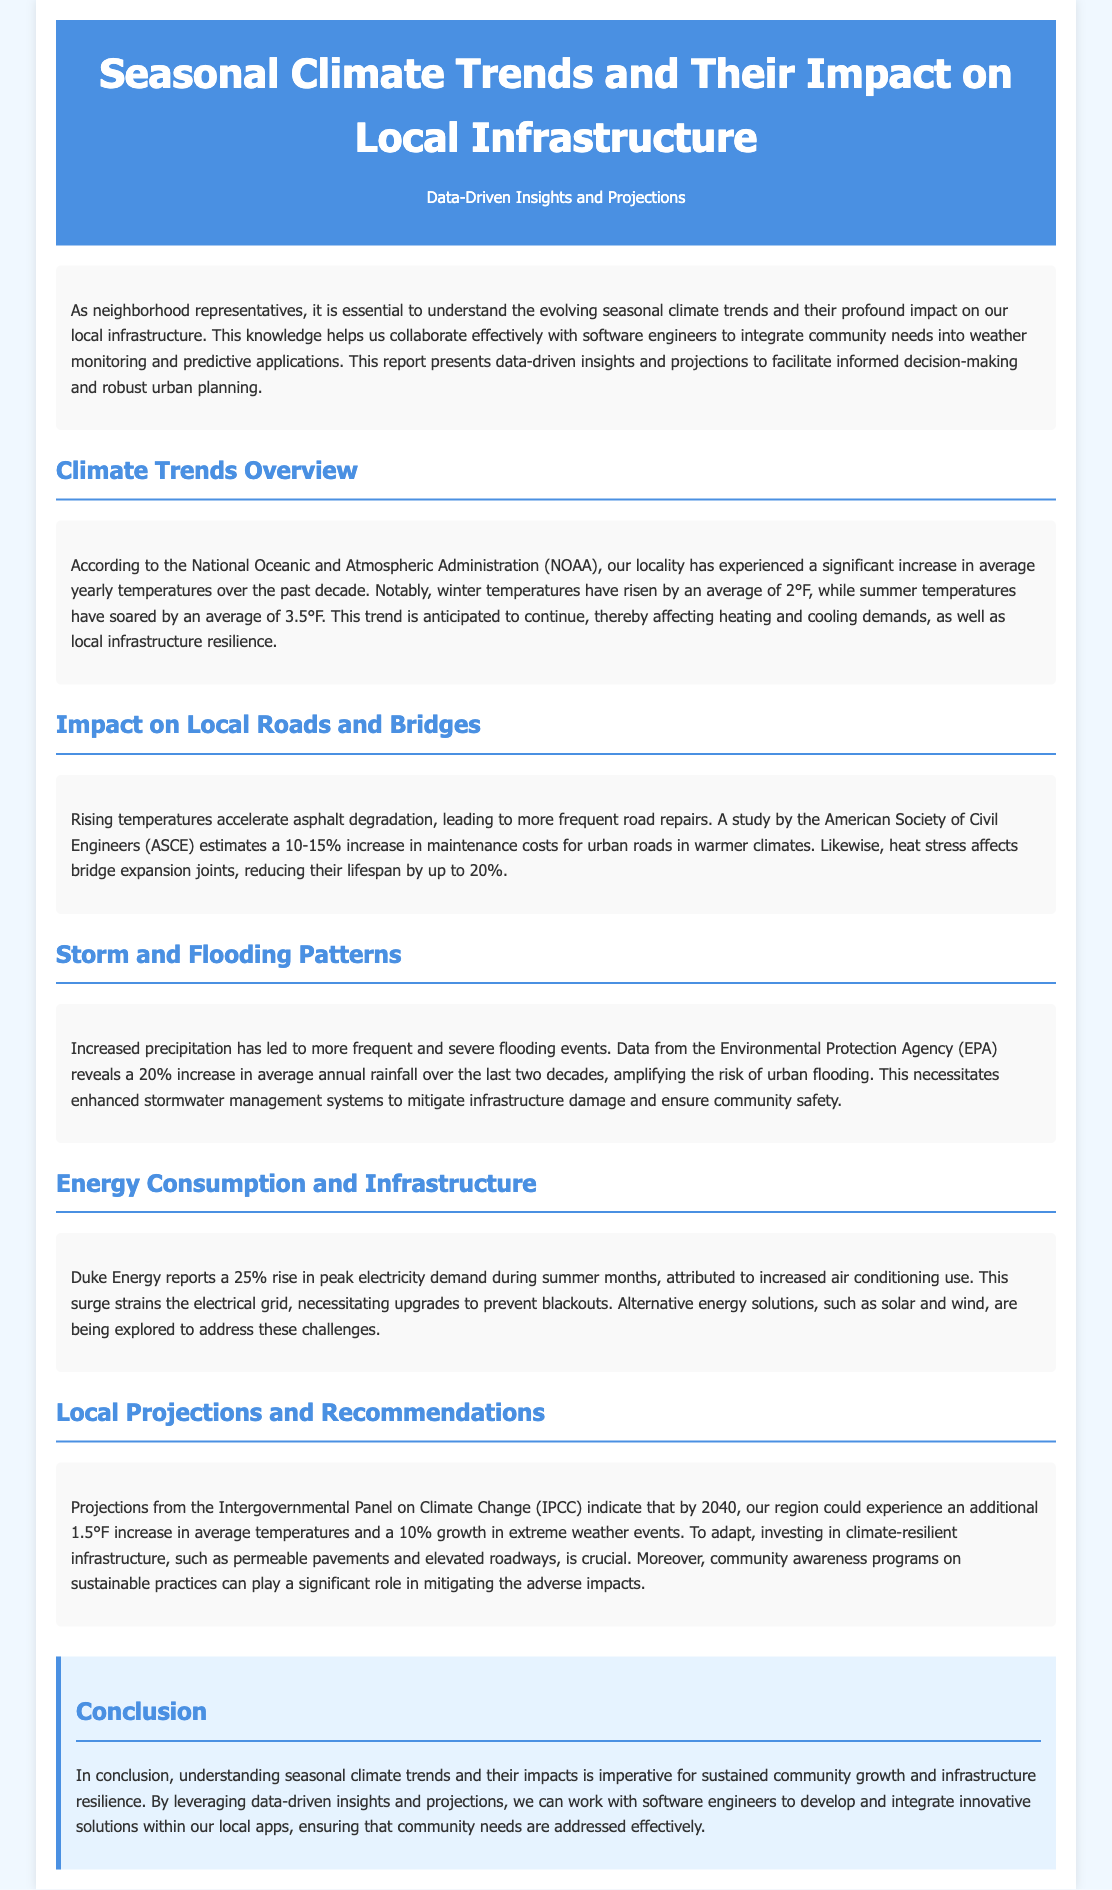What is the average increase in winter temperatures over the past decade? The document states that winter temperatures have risen by an average of 2°F over the past decade.
Answer: 2°F What is the estimated increase in maintenance costs for urban roads in warmer climates? According to the study by ASCE, there is a 10-15% increase in maintenance costs for urban roads in warmer climates.
Answer: 10-15% What percentage increase in average annual rainfall has been observed over the last two decades? The document reveals a 20% increase in average annual rainfall over the last two decades.
Answer: 20% By how much could the average temperatures increase by 2040, according to IPCC projections? The projections from the IPCC indicate that average temperatures could increase by an additional 1.5°F by 2040.
Answer: 1.5°F What percentage rise in peak electricity demand during summer months has been reported by Duke Energy? Duke Energy reports a 25% rise in peak electricity demand during summer months.
Answer: 25% What type of infrastructure is recommended for investment to adapt to climate impacts? The document recommends investing in climate-resilient infrastructure, such as permeable pavements and elevated roadways.
Answer: Climate-resilient infrastructure What significant effect does rising temperatures have on asphalt? Rising temperatures accelerate asphalt degradation, leading to more frequent road repairs.
Answer: Asphalt degradation What is a proposed solution to address strain on the electrical grid? The document mentions exploring alternative energy solutions, such as solar and wind, to address this challenge.
Answer: Solar and wind Which organization provided data regarding the increase in flooding events? The data regarding increased flooding events is provided by the Environmental Protection Agency (EPA).
Answer: Environmental Protection Agency (EPA) 